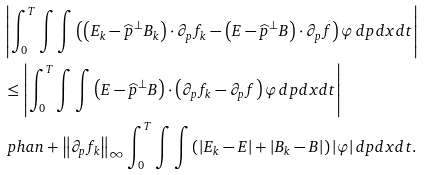Convert formula to latex. <formula><loc_0><loc_0><loc_500><loc_500>& \left | \int _ { 0 } ^ { T } { \int { \int { \left ( \left ( E _ { k } - \widehat { p } ^ { \bot } B _ { k } \right ) \cdot \partial _ { p } f _ { k } - \left ( E - \widehat { p } ^ { \bot } B \right ) \cdot \partial _ { p } f \right ) \varphi \, d p } d x } d t } \right | \\ & \leq \left | \int _ { 0 } ^ { T } { \int { \int { \left ( E - \widehat { p } ^ { \bot } B \right ) \cdot \left ( \partial _ { p } f _ { k } - \partial _ { p } f \right ) \varphi \, d p } d x } d t } \right | \\ & \ p h a n + \left \| \partial _ { p } f _ { k } \right \| _ { \infty } \int _ { 0 } ^ { T } { \int { \int { \left ( \left | E _ { k } - E \right | + \left | B _ { k } - B \right | \right ) \left | \varphi \right | d p } d x } d t } .</formula> 